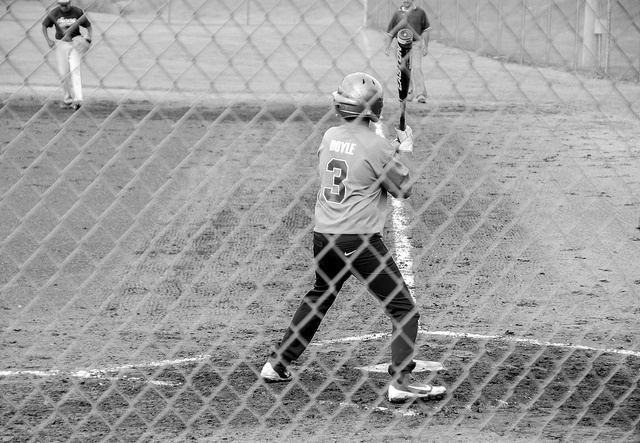Describe the objects in this image and their specific colors. I can see people in gray, darkgray, black, and lightgray tones, people in gray, darkgray, lightgray, and black tones, people in gray, darkgray, lightgray, and black tones, baseball bat in gray, black, darkgray, and lightgray tones, and baseball glove in gray, darkgray, lightgray, and black tones in this image. 